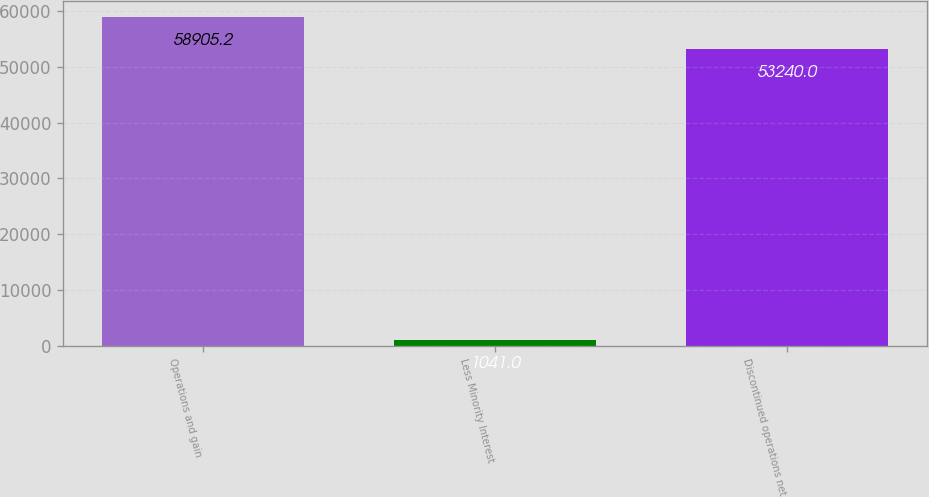Convert chart to OTSL. <chart><loc_0><loc_0><loc_500><loc_500><bar_chart><fcel>Operations and gain<fcel>Less Minority Interest<fcel>Discontinued operations net<nl><fcel>58905.2<fcel>1041<fcel>53240<nl></chart> 